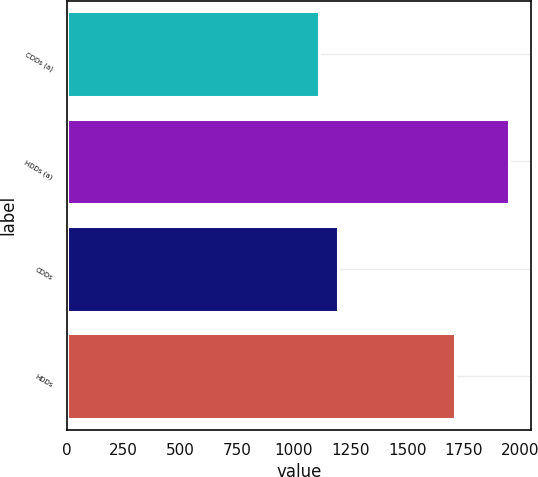Convert chart. <chart><loc_0><loc_0><loc_500><loc_500><bar_chart><fcel>CDDs (a)<fcel>HDDs (a)<fcel>CDDs<fcel>HDDs<nl><fcel>1111<fcel>1948<fcel>1194.7<fcel>1712<nl></chart> 